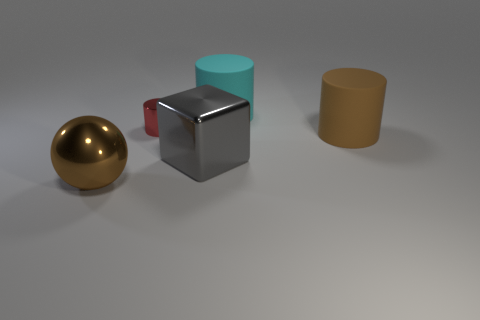What size is the brown shiny sphere?
Your answer should be compact. Large. Does the brown cylinder right of the big cyan object have the same material as the large cyan cylinder?
Give a very brief answer. Yes. How many blue things are there?
Offer a terse response. 0. How many objects are either tiny cyan shiny cylinders or large cubes?
Your answer should be very brief. 1. There is a big brown thing left of the big rubber thing in front of the big cyan rubber object; what number of large cyan rubber cylinders are on the left side of it?
Offer a very short reply. 0. Is there anything else of the same color as the shiny sphere?
Your answer should be very brief. Yes. There is a large cylinder in front of the tiny shiny cylinder; is its color the same as the ball in front of the big cyan object?
Your response must be concise. Yes. Is the number of big shiny cubes in front of the cyan rubber cylinder greater than the number of big cyan objects that are in front of the tiny shiny thing?
Your answer should be compact. Yes. What material is the red cylinder?
Make the answer very short. Metal. There is a large brown thing behind the large metal thing that is behind the brown thing that is in front of the big brown matte thing; what shape is it?
Keep it short and to the point. Cylinder. 